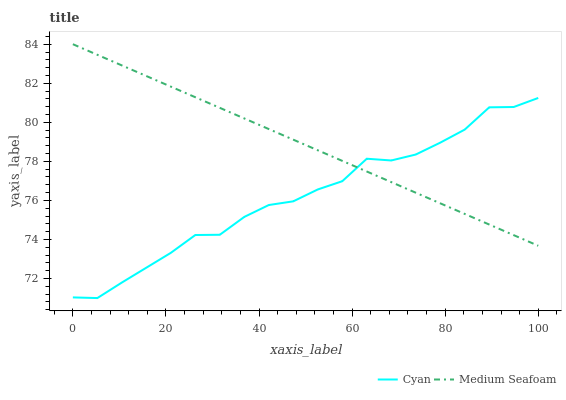Does Cyan have the minimum area under the curve?
Answer yes or no. Yes. Does Medium Seafoam have the maximum area under the curve?
Answer yes or no. Yes. Does Medium Seafoam have the minimum area under the curve?
Answer yes or no. No. Is Medium Seafoam the smoothest?
Answer yes or no. Yes. Is Cyan the roughest?
Answer yes or no. Yes. Is Medium Seafoam the roughest?
Answer yes or no. No. Does Cyan have the lowest value?
Answer yes or no. Yes. Does Medium Seafoam have the lowest value?
Answer yes or no. No. Does Medium Seafoam have the highest value?
Answer yes or no. Yes. Does Medium Seafoam intersect Cyan?
Answer yes or no. Yes. Is Medium Seafoam less than Cyan?
Answer yes or no. No. Is Medium Seafoam greater than Cyan?
Answer yes or no. No. 